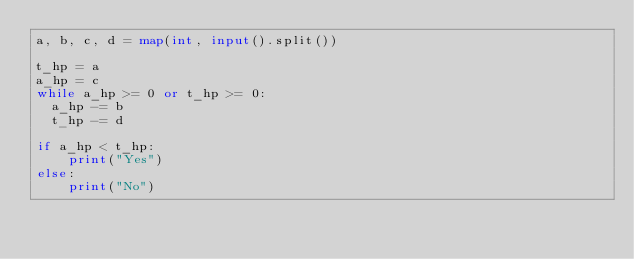<code> <loc_0><loc_0><loc_500><loc_500><_Python_>a, b, c, d = map(int, input().split())

t_hp = a
a_hp = c
while a_hp >= 0 or t_hp >= 0:
	a_hp -= b
	t_hp -= d

if a_hp < t_hp:
  	print("Yes")
else:
  	print("No")
</code> 